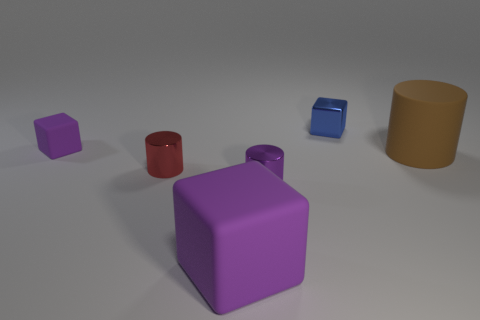There is a big purple thing that is made of the same material as the small purple cube; what is its shape?
Offer a terse response. Cube. Are there more purple shiny things that are in front of the big purple cube than blue metal blocks?
Your response must be concise. No. How many large objects are the same color as the small matte block?
Your answer should be compact. 1. How many other things are there of the same color as the tiny rubber block?
Provide a succinct answer. 2. Is the number of purple cylinders greater than the number of tiny blue cylinders?
Provide a short and direct response. Yes. What is the small purple cylinder made of?
Your answer should be compact. Metal. Is the size of the rubber object on the right side of the blue metal object the same as the tiny rubber thing?
Your answer should be very brief. No. There is a metallic object that is on the right side of the purple shiny cylinder; what is its size?
Make the answer very short. Small. How many large spheres are there?
Give a very brief answer. 0. Do the matte cylinder and the metal block have the same color?
Your response must be concise. No. 